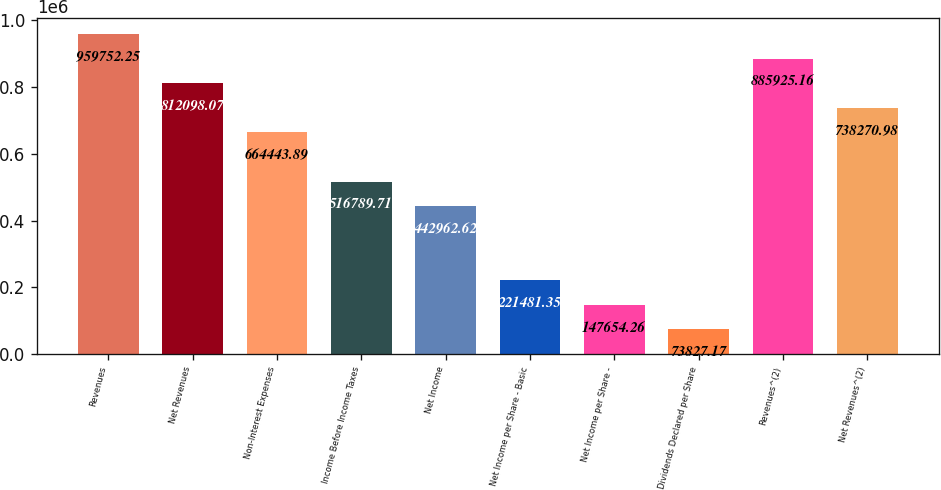<chart> <loc_0><loc_0><loc_500><loc_500><bar_chart><fcel>Revenues<fcel>Net Revenues<fcel>Non-Interest Expenses<fcel>Income Before Income Taxes<fcel>Net Income<fcel>Net Income per Share - Basic<fcel>Net Income per Share -<fcel>Dividends Declared per Share<fcel>Revenues^(2)<fcel>Net Revenues^(2)<nl><fcel>959752<fcel>812098<fcel>664444<fcel>516790<fcel>442963<fcel>221481<fcel>147654<fcel>73827.2<fcel>885925<fcel>738271<nl></chart> 